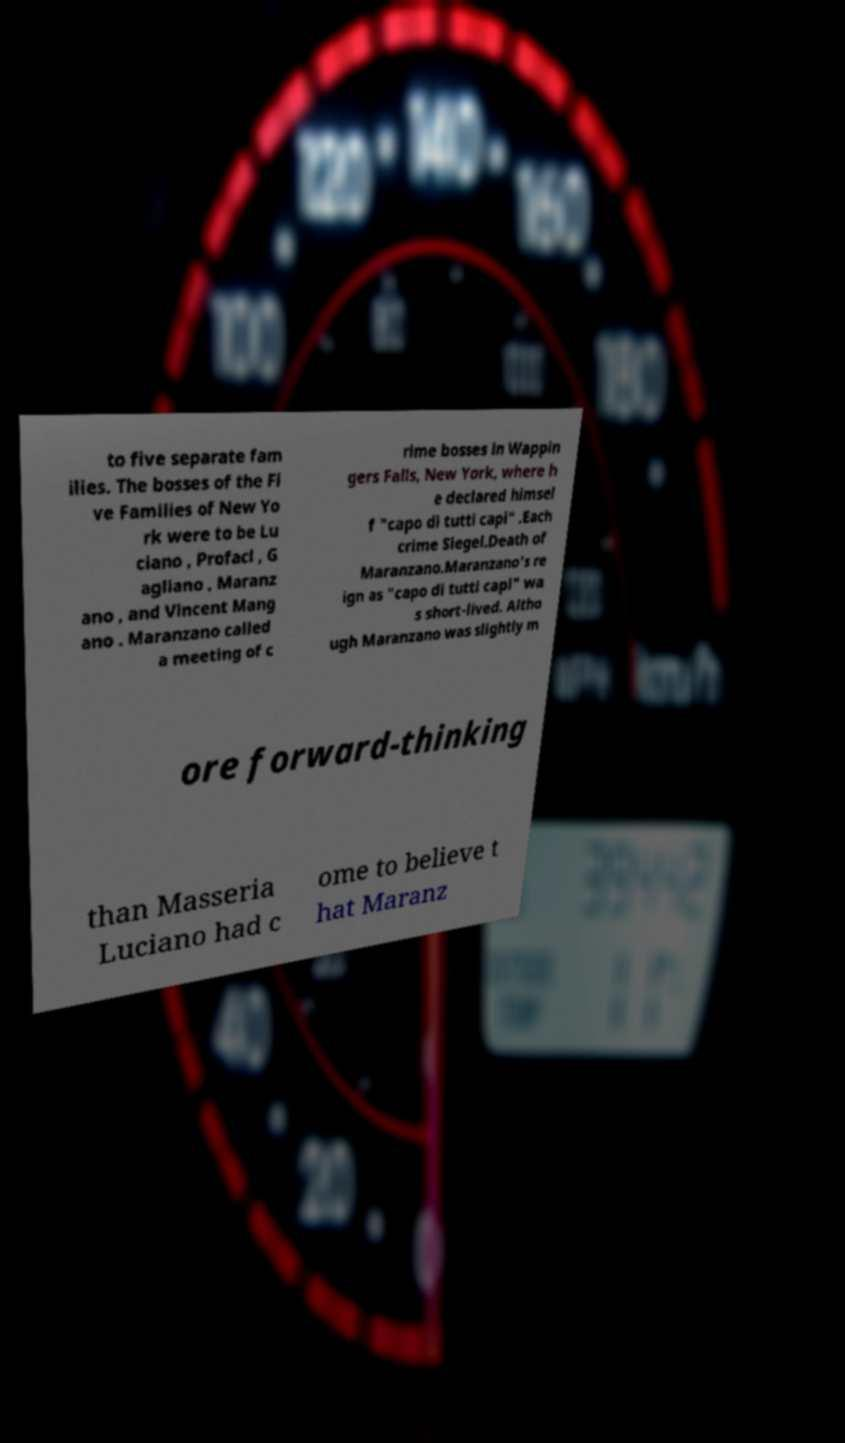For documentation purposes, I need the text within this image transcribed. Could you provide that? to five separate fam ilies. The bosses of the Fi ve Families of New Yo rk were to be Lu ciano , Profaci , G agliano , Maranz ano , and Vincent Mang ano . Maranzano called a meeting of c rime bosses in Wappin gers Falls, New York, where h e declared himsel f "capo di tutti capi" .Each crime Siegel.Death of Maranzano.Maranzano's re ign as "capo di tutti capi" wa s short-lived. Altho ugh Maranzano was slightly m ore forward-thinking than Masseria Luciano had c ome to believe t hat Maranz 